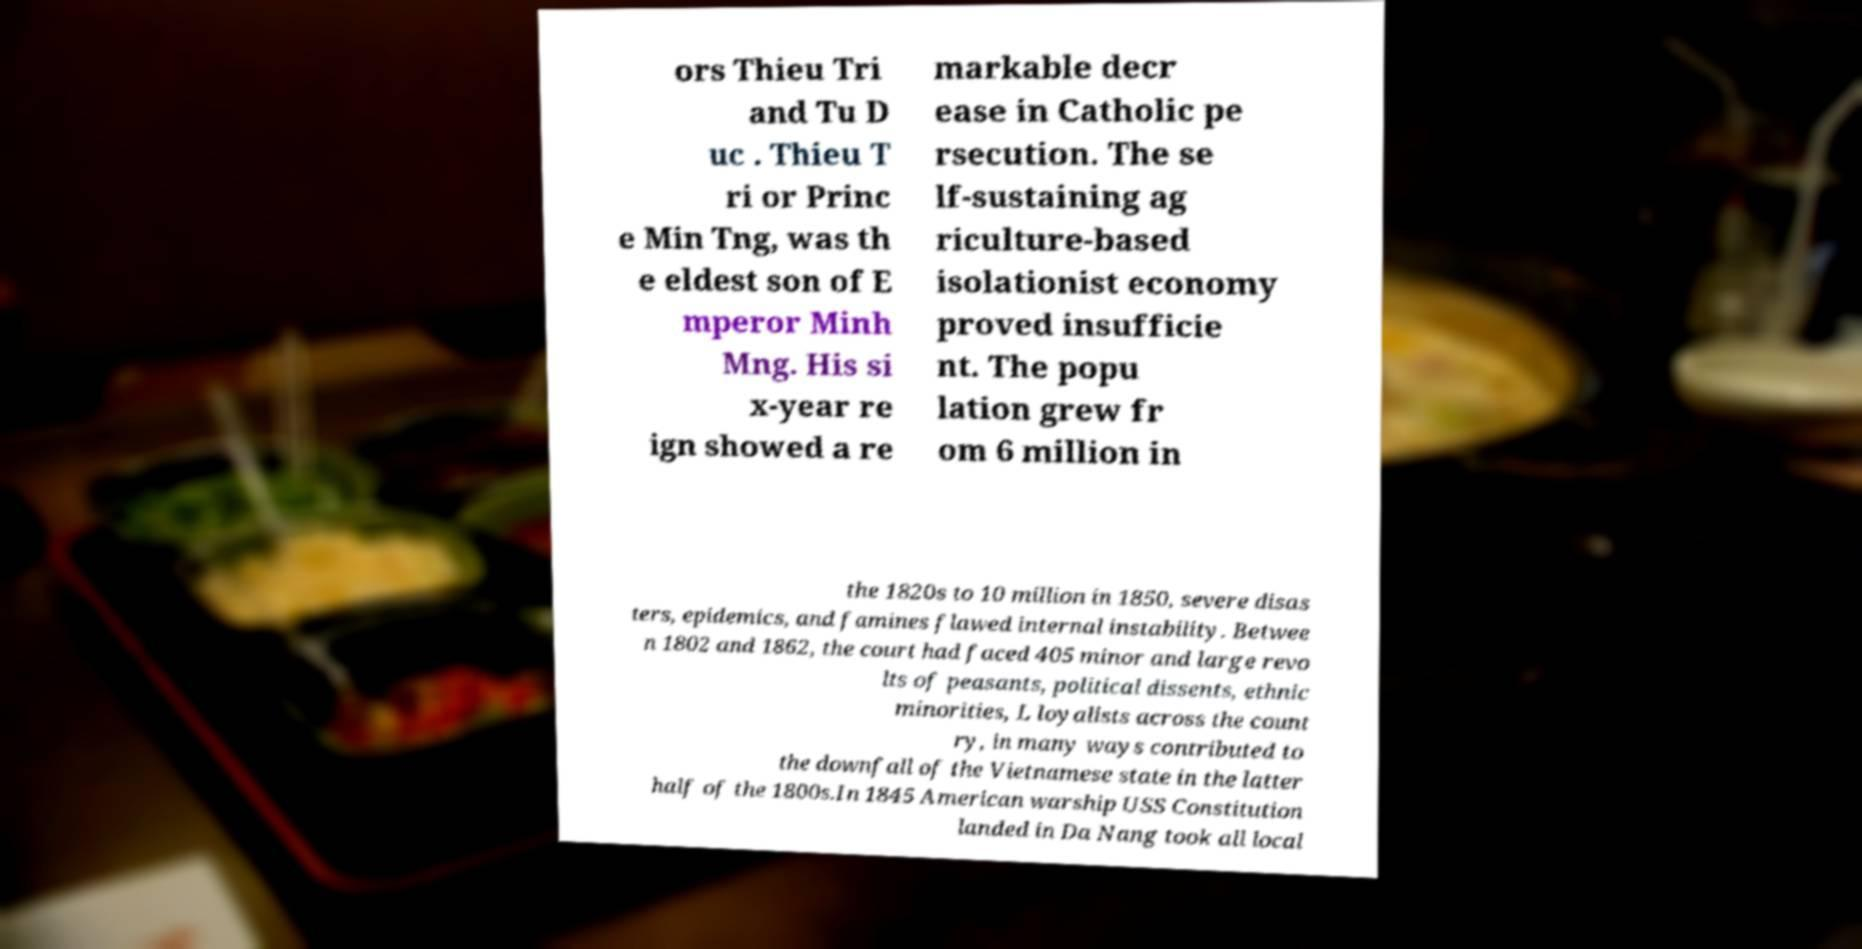What messages or text are displayed in this image? I need them in a readable, typed format. ors Thieu Tri and Tu D uc . Thieu T ri or Princ e Min Tng, was th e eldest son of E mperor Minh Mng. His si x-year re ign showed a re markable decr ease in Catholic pe rsecution. The se lf-sustaining ag riculture-based isolationist economy proved insufficie nt. The popu lation grew fr om 6 million in the 1820s to 10 million in 1850, severe disas ters, epidemics, and famines flawed internal instability. Betwee n 1802 and 1862, the court had faced 405 minor and large revo lts of peasants, political dissents, ethnic minorities, L loyalists across the count ry, in many ways contributed to the downfall of the Vietnamese state in the latter half of the 1800s.In 1845 American warship USS Constitution landed in Da Nang took all local 